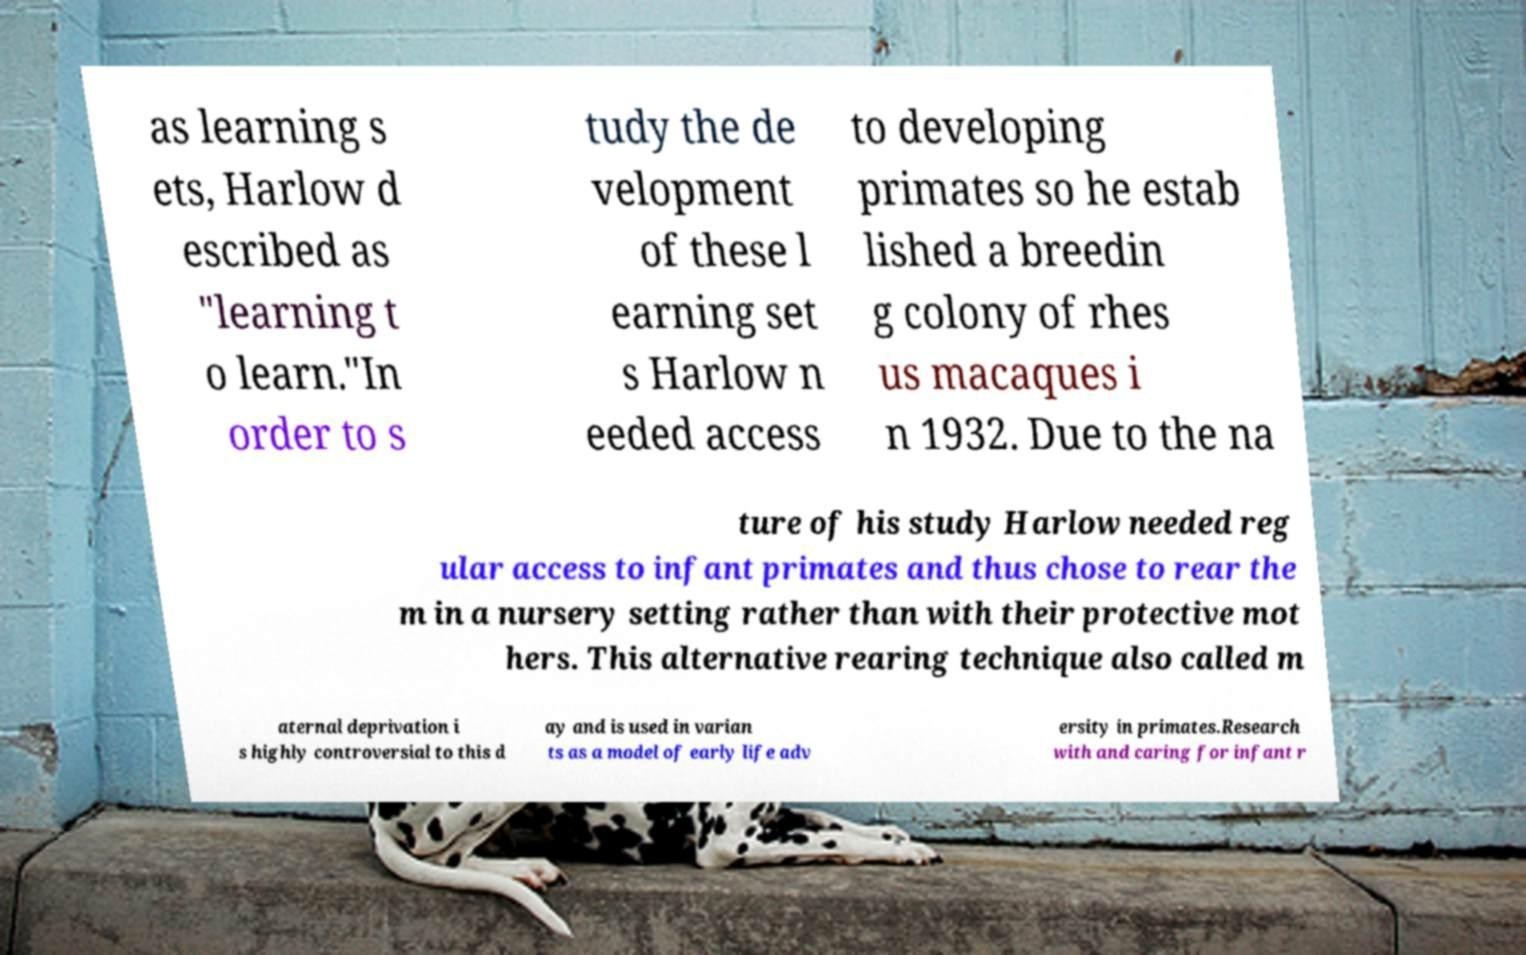Could you extract and type out the text from this image? as learning s ets, Harlow d escribed as "learning t o learn."In order to s tudy the de velopment of these l earning set s Harlow n eeded access to developing primates so he estab lished a breedin g colony of rhes us macaques i n 1932. Due to the na ture of his study Harlow needed reg ular access to infant primates and thus chose to rear the m in a nursery setting rather than with their protective mot hers. This alternative rearing technique also called m aternal deprivation i s highly controversial to this d ay and is used in varian ts as a model of early life adv ersity in primates.Research with and caring for infant r 